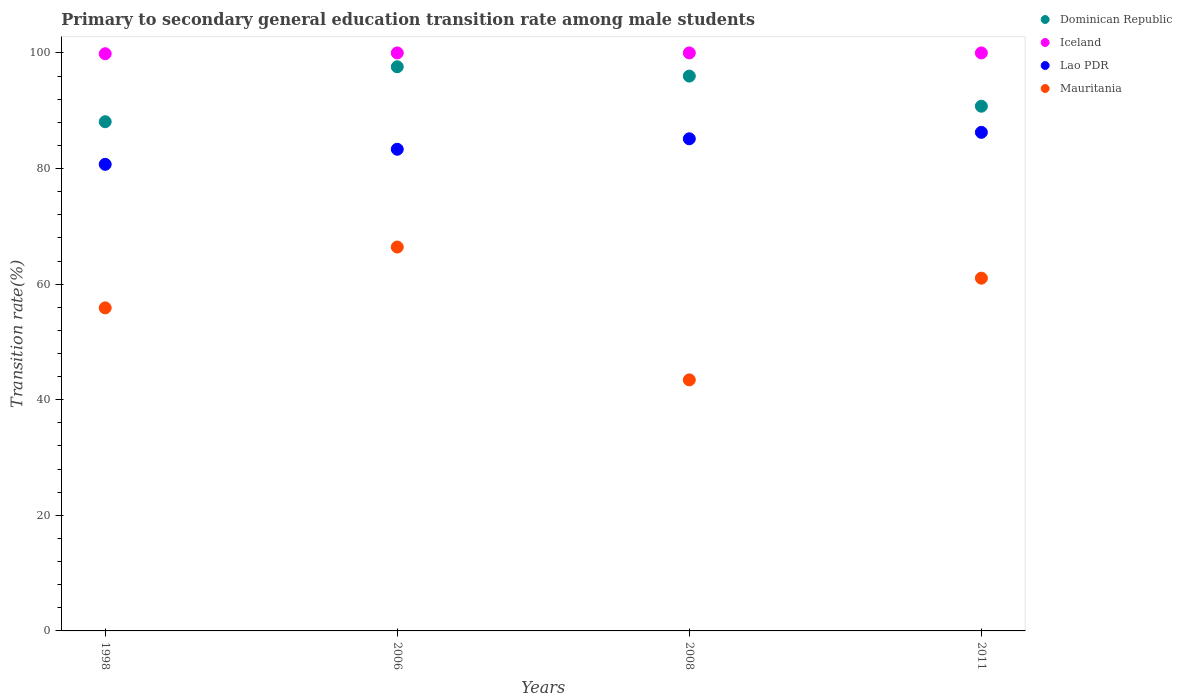What is the transition rate in Dominican Republic in 2011?
Provide a succinct answer. 90.78. Across all years, what is the maximum transition rate in Iceland?
Provide a short and direct response. 100. Across all years, what is the minimum transition rate in Dominican Republic?
Your answer should be very brief. 88.1. In which year was the transition rate in Dominican Republic minimum?
Offer a terse response. 1998. What is the total transition rate in Iceland in the graph?
Provide a short and direct response. 399.86. What is the difference between the transition rate in Dominican Republic in 1998 and that in 2006?
Your answer should be very brief. -9.51. What is the difference between the transition rate in Dominican Republic in 1998 and the transition rate in Mauritania in 2011?
Your answer should be very brief. 27.07. What is the average transition rate in Dominican Republic per year?
Provide a succinct answer. 93.12. In the year 1998, what is the difference between the transition rate in Mauritania and transition rate in Iceland?
Provide a succinct answer. -43.97. Is the transition rate in Lao PDR in 1998 less than that in 2011?
Ensure brevity in your answer.  Yes. Is the difference between the transition rate in Mauritania in 1998 and 2006 greater than the difference between the transition rate in Iceland in 1998 and 2006?
Keep it short and to the point. No. What is the difference between the highest and the lowest transition rate in Dominican Republic?
Make the answer very short. 9.51. In how many years, is the transition rate in Dominican Republic greater than the average transition rate in Dominican Republic taken over all years?
Provide a short and direct response. 2. Is the sum of the transition rate in Iceland in 2008 and 2011 greater than the maximum transition rate in Mauritania across all years?
Keep it short and to the point. Yes. Is it the case that in every year, the sum of the transition rate in Dominican Republic and transition rate in Lao PDR  is greater than the transition rate in Mauritania?
Your answer should be compact. Yes. Is the transition rate in Dominican Republic strictly greater than the transition rate in Mauritania over the years?
Keep it short and to the point. Yes. Is the transition rate in Dominican Republic strictly less than the transition rate in Mauritania over the years?
Your answer should be compact. No. How many years are there in the graph?
Your answer should be very brief. 4. Does the graph contain any zero values?
Your answer should be compact. No. Does the graph contain grids?
Give a very brief answer. No. What is the title of the graph?
Your response must be concise. Primary to secondary general education transition rate among male students. What is the label or title of the X-axis?
Keep it short and to the point. Years. What is the label or title of the Y-axis?
Offer a very short reply. Transition rate(%). What is the Transition rate(%) in Dominican Republic in 1998?
Keep it short and to the point. 88.1. What is the Transition rate(%) of Iceland in 1998?
Your answer should be very brief. 99.86. What is the Transition rate(%) of Lao PDR in 1998?
Your response must be concise. 80.72. What is the Transition rate(%) in Mauritania in 1998?
Keep it short and to the point. 55.89. What is the Transition rate(%) of Dominican Republic in 2006?
Ensure brevity in your answer.  97.6. What is the Transition rate(%) in Lao PDR in 2006?
Give a very brief answer. 83.33. What is the Transition rate(%) of Mauritania in 2006?
Offer a very short reply. 66.41. What is the Transition rate(%) in Dominican Republic in 2008?
Provide a short and direct response. 95.99. What is the Transition rate(%) of Lao PDR in 2008?
Your answer should be very brief. 85.15. What is the Transition rate(%) of Mauritania in 2008?
Offer a terse response. 43.43. What is the Transition rate(%) of Dominican Republic in 2011?
Offer a very short reply. 90.78. What is the Transition rate(%) in Iceland in 2011?
Give a very brief answer. 100. What is the Transition rate(%) in Lao PDR in 2011?
Provide a short and direct response. 86.26. What is the Transition rate(%) of Mauritania in 2011?
Make the answer very short. 61.03. Across all years, what is the maximum Transition rate(%) of Dominican Republic?
Make the answer very short. 97.6. Across all years, what is the maximum Transition rate(%) of Lao PDR?
Ensure brevity in your answer.  86.26. Across all years, what is the maximum Transition rate(%) in Mauritania?
Offer a very short reply. 66.41. Across all years, what is the minimum Transition rate(%) in Dominican Republic?
Offer a terse response. 88.1. Across all years, what is the minimum Transition rate(%) in Iceland?
Your response must be concise. 99.86. Across all years, what is the minimum Transition rate(%) of Lao PDR?
Offer a very short reply. 80.72. Across all years, what is the minimum Transition rate(%) in Mauritania?
Your answer should be very brief. 43.43. What is the total Transition rate(%) in Dominican Republic in the graph?
Provide a short and direct response. 372.47. What is the total Transition rate(%) in Iceland in the graph?
Give a very brief answer. 399.86. What is the total Transition rate(%) in Lao PDR in the graph?
Ensure brevity in your answer.  335.46. What is the total Transition rate(%) in Mauritania in the graph?
Provide a succinct answer. 226.77. What is the difference between the Transition rate(%) of Dominican Republic in 1998 and that in 2006?
Offer a terse response. -9.51. What is the difference between the Transition rate(%) in Iceland in 1998 and that in 2006?
Ensure brevity in your answer.  -0.14. What is the difference between the Transition rate(%) of Lao PDR in 1998 and that in 2006?
Offer a very short reply. -2.61. What is the difference between the Transition rate(%) of Mauritania in 1998 and that in 2006?
Offer a very short reply. -10.52. What is the difference between the Transition rate(%) in Dominican Republic in 1998 and that in 2008?
Your answer should be compact. -7.89. What is the difference between the Transition rate(%) of Iceland in 1998 and that in 2008?
Provide a succinct answer. -0.14. What is the difference between the Transition rate(%) in Lao PDR in 1998 and that in 2008?
Your answer should be very brief. -4.42. What is the difference between the Transition rate(%) in Mauritania in 1998 and that in 2008?
Make the answer very short. 12.46. What is the difference between the Transition rate(%) of Dominican Republic in 1998 and that in 2011?
Provide a short and direct response. -2.68. What is the difference between the Transition rate(%) in Iceland in 1998 and that in 2011?
Your answer should be very brief. -0.14. What is the difference between the Transition rate(%) of Lao PDR in 1998 and that in 2011?
Your answer should be compact. -5.54. What is the difference between the Transition rate(%) in Mauritania in 1998 and that in 2011?
Provide a succinct answer. -5.14. What is the difference between the Transition rate(%) of Dominican Republic in 2006 and that in 2008?
Keep it short and to the point. 1.61. What is the difference between the Transition rate(%) of Iceland in 2006 and that in 2008?
Make the answer very short. 0. What is the difference between the Transition rate(%) of Lao PDR in 2006 and that in 2008?
Provide a succinct answer. -1.81. What is the difference between the Transition rate(%) of Mauritania in 2006 and that in 2008?
Keep it short and to the point. 22.98. What is the difference between the Transition rate(%) in Dominican Republic in 2006 and that in 2011?
Offer a terse response. 6.82. What is the difference between the Transition rate(%) of Iceland in 2006 and that in 2011?
Keep it short and to the point. 0. What is the difference between the Transition rate(%) of Lao PDR in 2006 and that in 2011?
Keep it short and to the point. -2.93. What is the difference between the Transition rate(%) in Mauritania in 2006 and that in 2011?
Your answer should be compact. 5.38. What is the difference between the Transition rate(%) of Dominican Republic in 2008 and that in 2011?
Your answer should be compact. 5.21. What is the difference between the Transition rate(%) in Lao PDR in 2008 and that in 2011?
Your answer should be compact. -1.11. What is the difference between the Transition rate(%) of Mauritania in 2008 and that in 2011?
Give a very brief answer. -17.6. What is the difference between the Transition rate(%) of Dominican Republic in 1998 and the Transition rate(%) of Iceland in 2006?
Give a very brief answer. -11.9. What is the difference between the Transition rate(%) in Dominican Republic in 1998 and the Transition rate(%) in Lao PDR in 2006?
Keep it short and to the point. 4.76. What is the difference between the Transition rate(%) of Dominican Republic in 1998 and the Transition rate(%) of Mauritania in 2006?
Your response must be concise. 21.68. What is the difference between the Transition rate(%) of Iceland in 1998 and the Transition rate(%) of Lao PDR in 2006?
Your answer should be very brief. 16.52. What is the difference between the Transition rate(%) of Iceland in 1998 and the Transition rate(%) of Mauritania in 2006?
Your response must be concise. 33.44. What is the difference between the Transition rate(%) in Lao PDR in 1998 and the Transition rate(%) in Mauritania in 2006?
Ensure brevity in your answer.  14.31. What is the difference between the Transition rate(%) of Dominican Republic in 1998 and the Transition rate(%) of Iceland in 2008?
Provide a short and direct response. -11.9. What is the difference between the Transition rate(%) in Dominican Republic in 1998 and the Transition rate(%) in Lao PDR in 2008?
Offer a very short reply. 2.95. What is the difference between the Transition rate(%) of Dominican Republic in 1998 and the Transition rate(%) of Mauritania in 2008?
Ensure brevity in your answer.  44.67. What is the difference between the Transition rate(%) of Iceland in 1998 and the Transition rate(%) of Lao PDR in 2008?
Make the answer very short. 14.71. What is the difference between the Transition rate(%) of Iceland in 1998 and the Transition rate(%) of Mauritania in 2008?
Provide a succinct answer. 56.43. What is the difference between the Transition rate(%) in Lao PDR in 1998 and the Transition rate(%) in Mauritania in 2008?
Your answer should be very brief. 37.29. What is the difference between the Transition rate(%) of Dominican Republic in 1998 and the Transition rate(%) of Iceland in 2011?
Ensure brevity in your answer.  -11.9. What is the difference between the Transition rate(%) of Dominican Republic in 1998 and the Transition rate(%) of Lao PDR in 2011?
Provide a succinct answer. 1.84. What is the difference between the Transition rate(%) of Dominican Republic in 1998 and the Transition rate(%) of Mauritania in 2011?
Your answer should be very brief. 27.07. What is the difference between the Transition rate(%) in Iceland in 1998 and the Transition rate(%) in Lao PDR in 2011?
Make the answer very short. 13.6. What is the difference between the Transition rate(%) in Iceland in 1998 and the Transition rate(%) in Mauritania in 2011?
Your answer should be compact. 38.83. What is the difference between the Transition rate(%) of Lao PDR in 1998 and the Transition rate(%) of Mauritania in 2011?
Your answer should be compact. 19.69. What is the difference between the Transition rate(%) of Dominican Republic in 2006 and the Transition rate(%) of Iceland in 2008?
Offer a very short reply. -2.4. What is the difference between the Transition rate(%) of Dominican Republic in 2006 and the Transition rate(%) of Lao PDR in 2008?
Your response must be concise. 12.46. What is the difference between the Transition rate(%) in Dominican Republic in 2006 and the Transition rate(%) in Mauritania in 2008?
Make the answer very short. 54.17. What is the difference between the Transition rate(%) in Iceland in 2006 and the Transition rate(%) in Lao PDR in 2008?
Your answer should be compact. 14.85. What is the difference between the Transition rate(%) of Iceland in 2006 and the Transition rate(%) of Mauritania in 2008?
Your answer should be very brief. 56.57. What is the difference between the Transition rate(%) in Lao PDR in 2006 and the Transition rate(%) in Mauritania in 2008?
Offer a very short reply. 39.9. What is the difference between the Transition rate(%) of Dominican Republic in 2006 and the Transition rate(%) of Iceland in 2011?
Provide a short and direct response. -2.4. What is the difference between the Transition rate(%) of Dominican Republic in 2006 and the Transition rate(%) of Lao PDR in 2011?
Make the answer very short. 11.34. What is the difference between the Transition rate(%) in Dominican Republic in 2006 and the Transition rate(%) in Mauritania in 2011?
Keep it short and to the point. 36.57. What is the difference between the Transition rate(%) of Iceland in 2006 and the Transition rate(%) of Lao PDR in 2011?
Your answer should be compact. 13.74. What is the difference between the Transition rate(%) of Iceland in 2006 and the Transition rate(%) of Mauritania in 2011?
Offer a very short reply. 38.97. What is the difference between the Transition rate(%) in Lao PDR in 2006 and the Transition rate(%) in Mauritania in 2011?
Offer a terse response. 22.3. What is the difference between the Transition rate(%) in Dominican Republic in 2008 and the Transition rate(%) in Iceland in 2011?
Give a very brief answer. -4.01. What is the difference between the Transition rate(%) of Dominican Republic in 2008 and the Transition rate(%) of Lao PDR in 2011?
Offer a terse response. 9.73. What is the difference between the Transition rate(%) of Dominican Republic in 2008 and the Transition rate(%) of Mauritania in 2011?
Ensure brevity in your answer.  34.96. What is the difference between the Transition rate(%) in Iceland in 2008 and the Transition rate(%) in Lao PDR in 2011?
Give a very brief answer. 13.74. What is the difference between the Transition rate(%) of Iceland in 2008 and the Transition rate(%) of Mauritania in 2011?
Offer a very short reply. 38.97. What is the difference between the Transition rate(%) of Lao PDR in 2008 and the Transition rate(%) of Mauritania in 2011?
Provide a short and direct response. 24.12. What is the average Transition rate(%) of Dominican Republic per year?
Your response must be concise. 93.12. What is the average Transition rate(%) of Iceland per year?
Provide a short and direct response. 99.96. What is the average Transition rate(%) in Lao PDR per year?
Make the answer very short. 83.87. What is the average Transition rate(%) of Mauritania per year?
Provide a short and direct response. 56.69. In the year 1998, what is the difference between the Transition rate(%) in Dominican Republic and Transition rate(%) in Iceland?
Make the answer very short. -11.76. In the year 1998, what is the difference between the Transition rate(%) in Dominican Republic and Transition rate(%) in Lao PDR?
Your answer should be compact. 7.37. In the year 1998, what is the difference between the Transition rate(%) in Dominican Republic and Transition rate(%) in Mauritania?
Provide a short and direct response. 32.21. In the year 1998, what is the difference between the Transition rate(%) in Iceland and Transition rate(%) in Lao PDR?
Provide a succinct answer. 19.13. In the year 1998, what is the difference between the Transition rate(%) in Iceland and Transition rate(%) in Mauritania?
Offer a terse response. 43.97. In the year 1998, what is the difference between the Transition rate(%) of Lao PDR and Transition rate(%) of Mauritania?
Your answer should be very brief. 24.83. In the year 2006, what is the difference between the Transition rate(%) of Dominican Republic and Transition rate(%) of Iceland?
Keep it short and to the point. -2.4. In the year 2006, what is the difference between the Transition rate(%) in Dominican Republic and Transition rate(%) in Lao PDR?
Provide a short and direct response. 14.27. In the year 2006, what is the difference between the Transition rate(%) in Dominican Republic and Transition rate(%) in Mauritania?
Offer a terse response. 31.19. In the year 2006, what is the difference between the Transition rate(%) of Iceland and Transition rate(%) of Lao PDR?
Give a very brief answer. 16.67. In the year 2006, what is the difference between the Transition rate(%) in Iceland and Transition rate(%) in Mauritania?
Keep it short and to the point. 33.59. In the year 2006, what is the difference between the Transition rate(%) of Lao PDR and Transition rate(%) of Mauritania?
Your response must be concise. 16.92. In the year 2008, what is the difference between the Transition rate(%) of Dominican Republic and Transition rate(%) of Iceland?
Offer a very short reply. -4.01. In the year 2008, what is the difference between the Transition rate(%) in Dominican Republic and Transition rate(%) in Lao PDR?
Your response must be concise. 10.85. In the year 2008, what is the difference between the Transition rate(%) of Dominican Republic and Transition rate(%) of Mauritania?
Your answer should be very brief. 52.56. In the year 2008, what is the difference between the Transition rate(%) of Iceland and Transition rate(%) of Lao PDR?
Keep it short and to the point. 14.85. In the year 2008, what is the difference between the Transition rate(%) of Iceland and Transition rate(%) of Mauritania?
Offer a very short reply. 56.57. In the year 2008, what is the difference between the Transition rate(%) in Lao PDR and Transition rate(%) in Mauritania?
Your answer should be compact. 41.71. In the year 2011, what is the difference between the Transition rate(%) in Dominican Republic and Transition rate(%) in Iceland?
Offer a very short reply. -9.22. In the year 2011, what is the difference between the Transition rate(%) in Dominican Republic and Transition rate(%) in Lao PDR?
Provide a succinct answer. 4.52. In the year 2011, what is the difference between the Transition rate(%) of Dominican Republic and Transition rate(%) of Mauritania?
Your answer should be compact. 29.75. In the year 2011, what is the difference between the Transition rate(%) of Iceland and Transition rate(%) of Lao PDR?
Make the answer very short. 13.74. In the year 2011, what is the difference between the Transition rate(%) in Iceland and Transition rate(%) in Mauritania?
Provide a short and direct response. 38.97. In the year 2011, what is the difference between the Transition rate(%) in Lao PDR and Transition rate(%) in Mauritania?
Your response must be concise. 25.23. What is the ratio of the Transition rate(%) of Dominican Republic in 1998 to that in 2006?
Provide a short and direct response. 0.9. What is the ratio of the Transition rate(%) in Iceland in 1998 to that in 2006?
Give a very brief answer. 1. What is the ratio of the Transition rate(%) of Lao PDR in 1998 to that in 2006?
Your answer should be very brief. 0.97. What is the ratio of the Transition rate(%) in Mauritania in 1998 to that in 2006?
Offer a very short reply. 0.84. What is the ratio of the Transition rate(%) in Dominican Republic in 1998 to that in 2008?
Your response must be concise. 0.92. What is the ratio of the Transition rate(%) in Lao PDR in 1998 to that in 2008?
Give a very brief answer. 0.95. What is the ratio of the Transition rate(%) in Mauritania in 1998 to that in 2008?
Give a very brief answer. 1.29. What is the ratio of the Transition rate(%) of Dominican Republic in 1998 to that in 2011?
Make the answer very short. 0.97. What is the ratio of the Transition rate(%) of Iceland in 1998 to that in 2011?
Keep it short and to the point. 1. What is the ratio of the Transition rate(%) in Lao PDR in 1998 to that in 2011?
Keep it short and to the point. 0.94. What is the ratio of the Transition rate(%) in Mauritania in 1998 to that in 2011?
Provide a short and direct response. 0.92. What is the ratio of the Transition rate(%) of Dominican Republic in 2006 to that in 2008?
Your response must be concise. 1.02. What is the ratio of the Transition rate(%) in Iceland in 2006 to that in 2008?
Your answer should be very brief. 1. What is the ratio of the Transition rate(%) of Lao PDR in 2006 to that in 2008?
Offer a very short reply. 0.98. What is the ratio of the Transition rate(%) of Mauritania in 2006 to that in 2008?
Give a very brief answer. 1.53. What is the ratio of the Transition rate(%) in Dominican Republic in 2006 to that in 2011?
Your response must be concise. 1.08. What is the ratio of the Transition rate(%) in Iceland in 2006 to that in 2011?
Your answer should be compact. 1. What is the ratio of the Transition rate(%) in Lao PDR in 2006 to that in 2011?
Give a very brief answer. 0.97. What is the ratio of the Transition rate(%) in Mauritania in 2006 to that in 2011?
Your answer should be compact. 1.09. What is the ratio of the Transition rate(%) of Dominican Republic in 2008 to that in 2011?
Ensure brevity in your answer.  1.06. What is the ratio of the Transition rate(%) in Iceland in 2008 to that in 2011?
Offer a very short reply. 1. What is the ratio of the Transition rate(%) of Lao PDR in 2008 to that in 2011?
Ensure brevity in your answer.  0.99. What is the ratio of the Transition rate(%) in Mauritania in 2008 to that in 2011?
Offer a very short reply. 0.71. What is the difference between the highest and the second highest Transition rate(%) of Dominican Republic?
Provide a succinct answer. 1.61. What is the difference between the highest and the second highest Transition rate(%) of Lao PDR?
Ensure brevity in your answer.  1.11. What is the difference between the highest and the second highest Transition rate(%) of Mauritania?
Keep it short and to the point. 5.38. What is the difference between the highest and the lowest Transition rate(%) in Dominican Republic?
Give a very brief answer. 9.51. What is the difference between the highest and the lowest Transition rate(%) in Iceland?
Make the answer very short. 0.14. What is the difference between the highest and the lowest Transition rate(%) of Lao PDR?
Your response must be concise. 5.54. What is the difference between the highest and the lowest Transition rate(%) of Mauritania?
Ensure brevity in your answer.  22.98. 